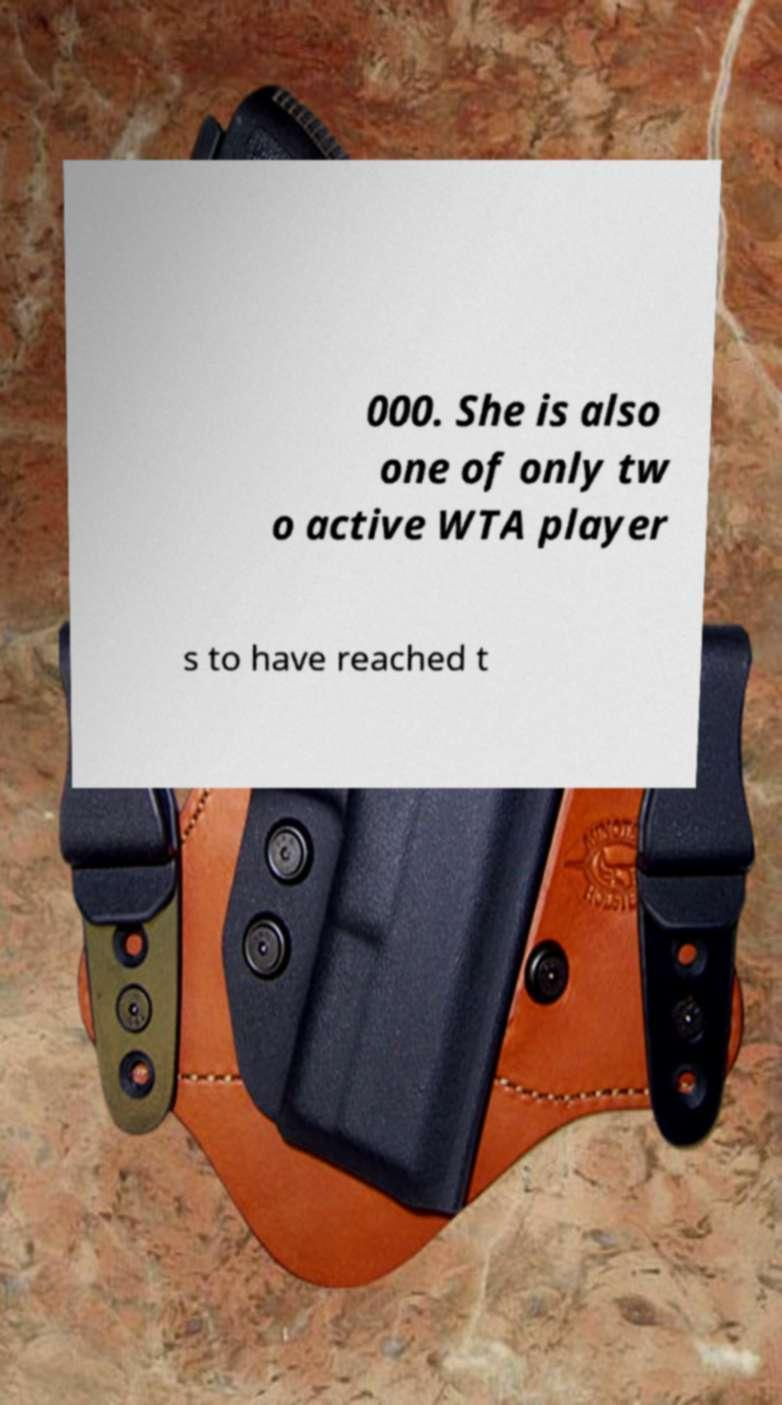There's text embedded in this image that I need extracted. Can you transcribe it verbatim? 000. She is also one of only tw o active WTA player s to have reached t 